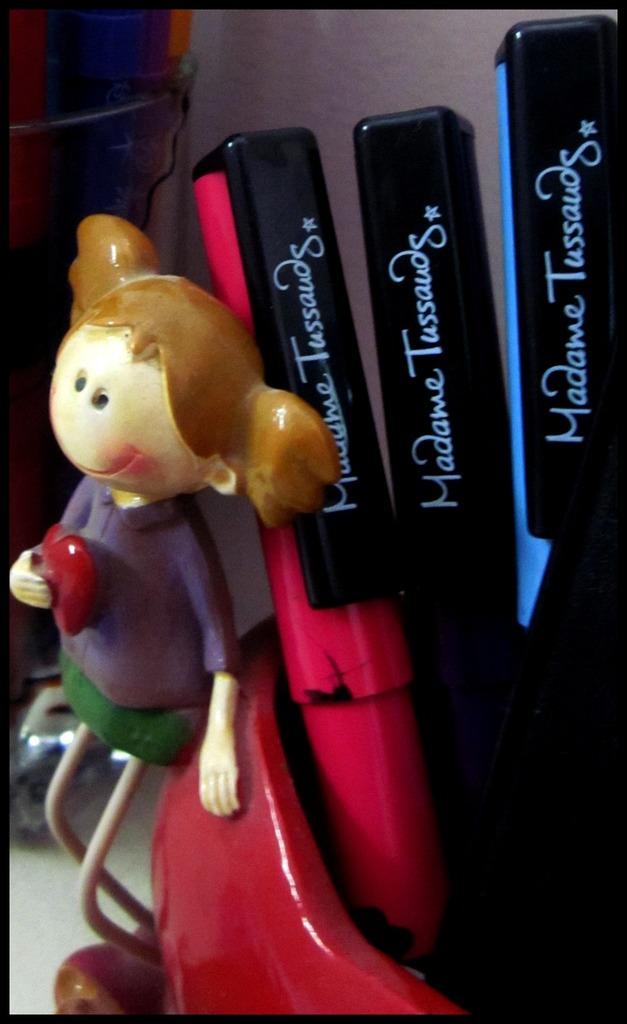What is the name on the three pens?
Keep it short and to the point. Madame tussauds. 